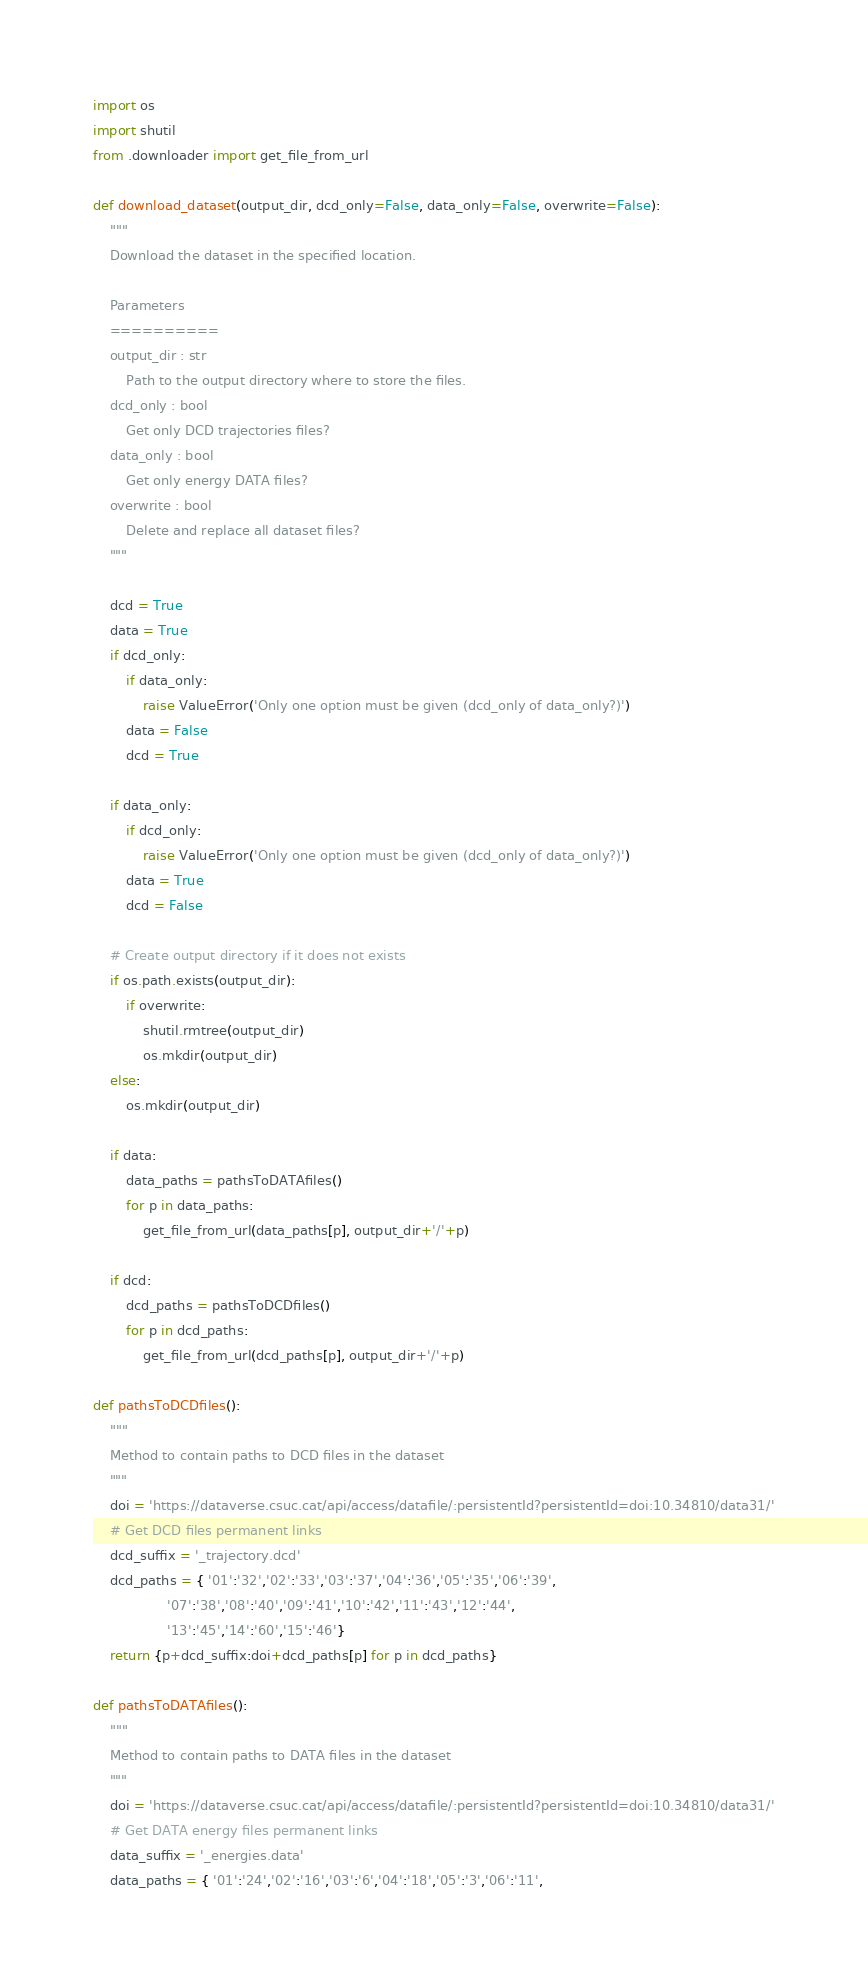<code> <loc_0><loc_0><loc_500><loc_500><_Python_>import os
import shutil
from .downloader import get_file_from_url

def download_dataset(output_dir, dcd_only=False, data_only=False, overwrite=False):
    """
    Download the dataset in the specified location.

    Parameters
    ==========
    output_dir : str
        Path to the output directory where to store the files.
    dcd_only : bool
        Get only DCD trajectories files?
    data_only : bool
        Get only energy DATA files?
    overwrite : bool
        Delete and replace all dataset files?
    """

    dcd = True
    data = True
    if dcd_only:
        if data_only:
            raise ValueError('Only one option must be given (dcd_only of data_only?)')
        data = False
        dcd = True

    if data_only:
        if dcd_only:
            raise ValueError('Only one option must be given (dcd_only of data_only?)')
        data = True
        dcd = False

    # Create output directory if it does not exists
    if os.path.exists(output_dir):
        if overwrite:
            shutil.rmtree(output_dir)
            os.mkdir(output_dir)
    else:
        os.mkdir(output_dir)

    if data:
        data_paths = pathsToDATAfiles()
        for p in data_paths:
            get_file_from_url(data_paths[p], output_dir+'/'+p)

    if dcd:
        dcd_paths = pathsToDCDfiles()
        for p in dcd_paths:
            get_file_from_url(dcd_paths[p], output_dir+'/'+p)

def pathsToDCDfiles():
    """
    Method to contain paths to DCD files in the dataset
    """
    doi = 'https://dataverse.csuc.cat/api/access/datafile/:persistentId?persistentId=doi:10.34810/data31/'
    # Get DCD files permanent links
    dcd_suffix = '_trajectory.dcd'
    dcd_paths = { '01':'32','02':'33','03':'37','04':'36','05':'35','06':'39',
                  '07':'38','08':'40','09':'41','10':'42','11':'43','12':'44',
                  '13':'45','14':'60','15':'46'}
    return {p+dcd_suffix:doi+dcd_paths[p] for p in dcd_paths}

def pathsToDATAfiles():
    """
    Method to contain paths to DATA files in the dataset
    """
    doi = 'https://dataverse.csuc.cat/api/access/datafile/:persistentId?persistentId=doi:10.34810/data31/'
    # Get DATA energy files permanent links
    data_suffix = '_energies.data'
    data_paths = { '01':'24','02':'16','03':'6','04':'18','05':'3','06':'11',</code> 